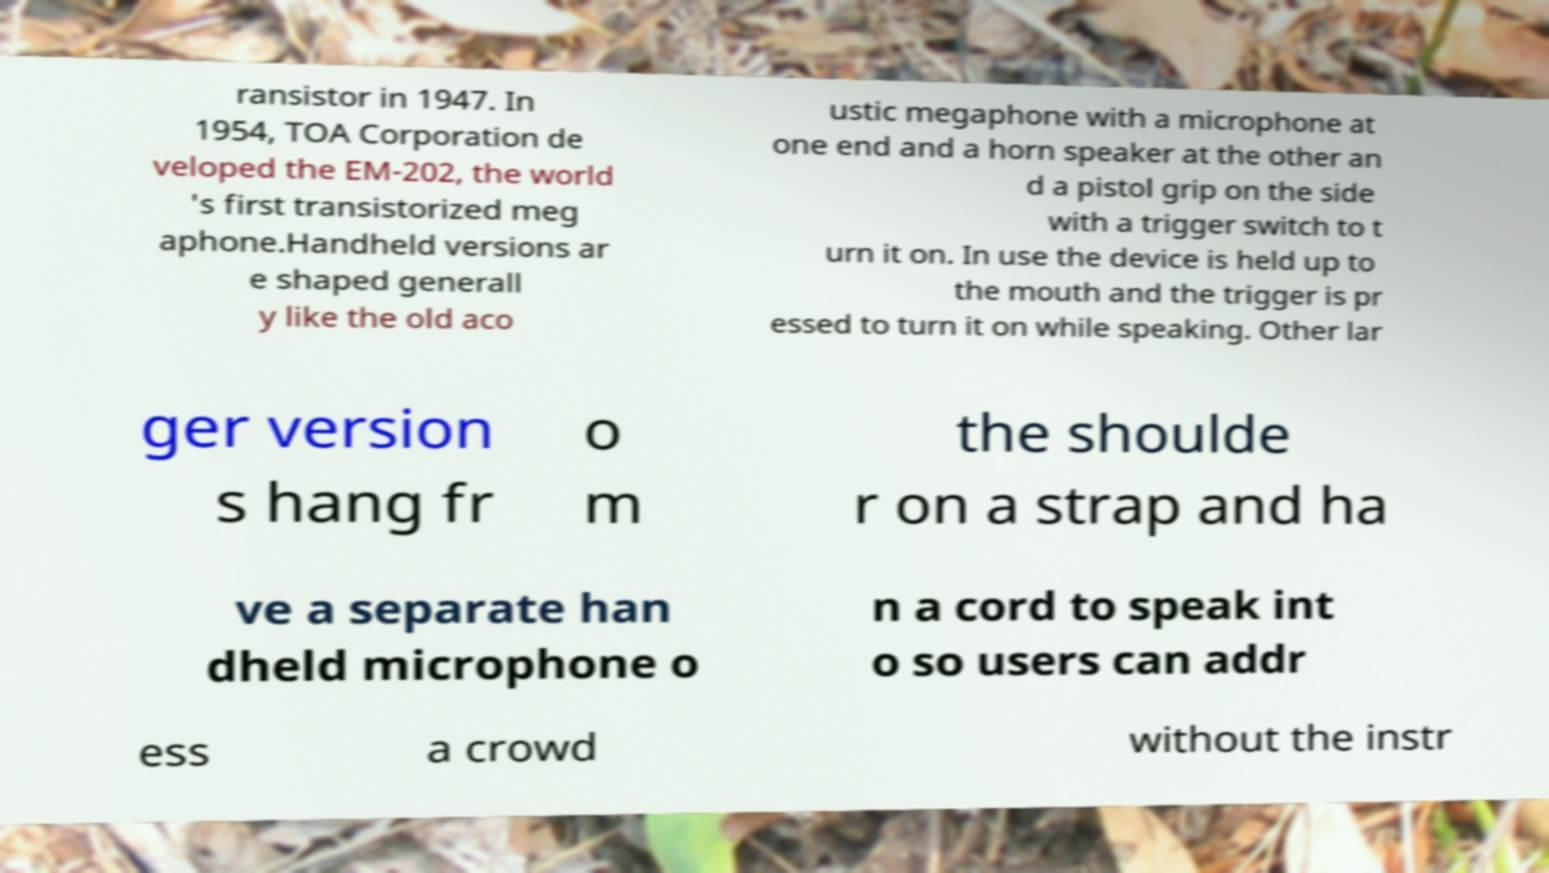Please identify and transcribe the text found in this image. ransistor in 1947. In 1954, TOA Corporation de veloped the EM-202, the world 's first transistorized meg aphone.Handheld versions ar e shaped generall y like the old aco ustic megaphone with a microphone at one end and a horn speaker at the other an d a pistol grip on the side with a trigger switch to t urn it on. In use the device is held up to the mouth and the trigger is pr essed to turn it on while speaking. Other lar ger version s hang fr o m the shoulde r on a strap and ha ve a separate han dheld microphone o n a cord to speak int o so users can addr ess a crowd without the instr 